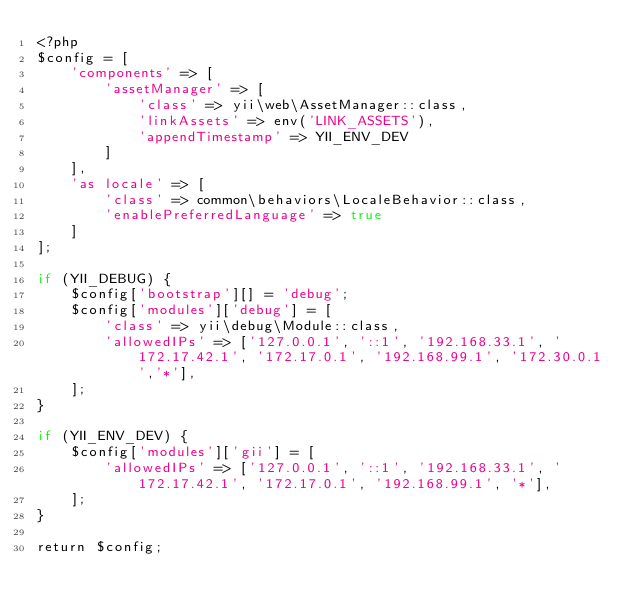Convert code to text. <code><loc_0><loc_0><loc_500><loc_500><_PHP_><?php
$config = [
    'components' => [
        'assetManager' => [
            'class' => yii\web\AssetManager::class,
            'linkAssets' => env('LINK_ASSETS'),
            'appendTimestamp' => YII_ENV_DEV
        ]
    ],
    'as locale' => [
        'class' => common\behaviors\LocaleBehavior::class,
        'enablePreferredLanguage' => true
    ]
];

if (YII_DEBUG) {
    $config['bootstrap'][] = 'debug';
    $config['modules']['debug'] = [
        'class' => yii\debug\Module::class,
        'allowedIPs' => ['127.0.0.1', '::1', '192.168.33.1', '172.17.42.1', '172.17.0.1', '192.168.99.1', '172.30.0.1','*'],
    ];
}

if (YII_ENV_DEV) {
    $config['modules']['gii'] = [
        'allowedIPs' => ['127.0.0.1', '::1', '192.168.33.1', '172.17.42.1', '172.17.0.1', '192.168.99.1', '*'],
    ];
}

return $config;
</code> 